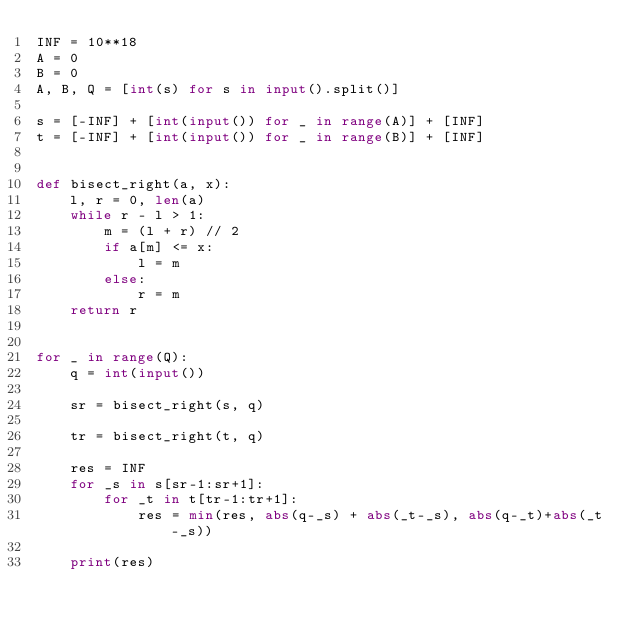<code> <loc_0><loc_0><loc_500><loc_500><_Python_>INF = 10**18
A = 0
B = 0
A, B, Q = [int(s) for s in input().split()]

s = [-INF] + [int(input()) for _ in range(A)] + [INF]
t = [-INF] + [int(input()) for _ in range(B)] + [INF]


def bisect_right(a, x):
    l, r = 0, len(a)
    while r - l > 1:
        m = (l + r) // 2
        if a[m] <= x:
            l = m
        else:
            r = m
    return r


for _ in range(Q):
    q = int(input())

    sr = bisect_right(s, q)

    tr = bisect_right(t, q)

    res = INF
    for _s in s[sr-1:sr+1]:
        for _t in t[tr-1:tr+1]:
            res = min(res, abs(q-_s) + abs(_t-_s), abs(q-_t)+abs(_t-_s))

    print(res)
</code> 